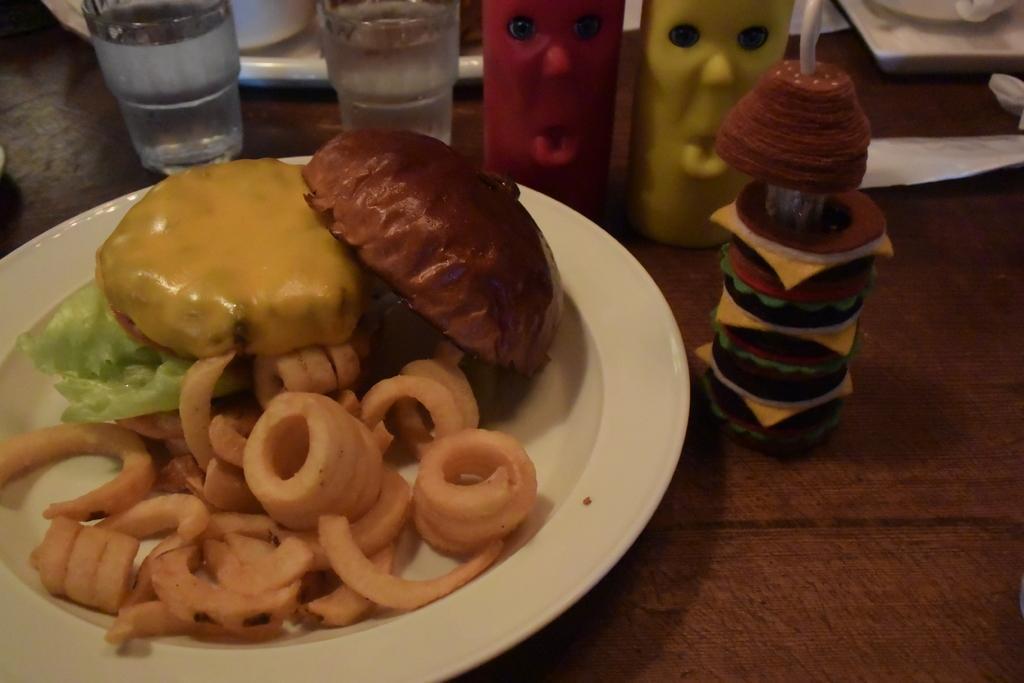In one or two sentences, can you explain what this image depicts? On the table we can see the glass, plate, straw and other objects. In the plate we can see the bread, cabbage, cheese and other food item. 